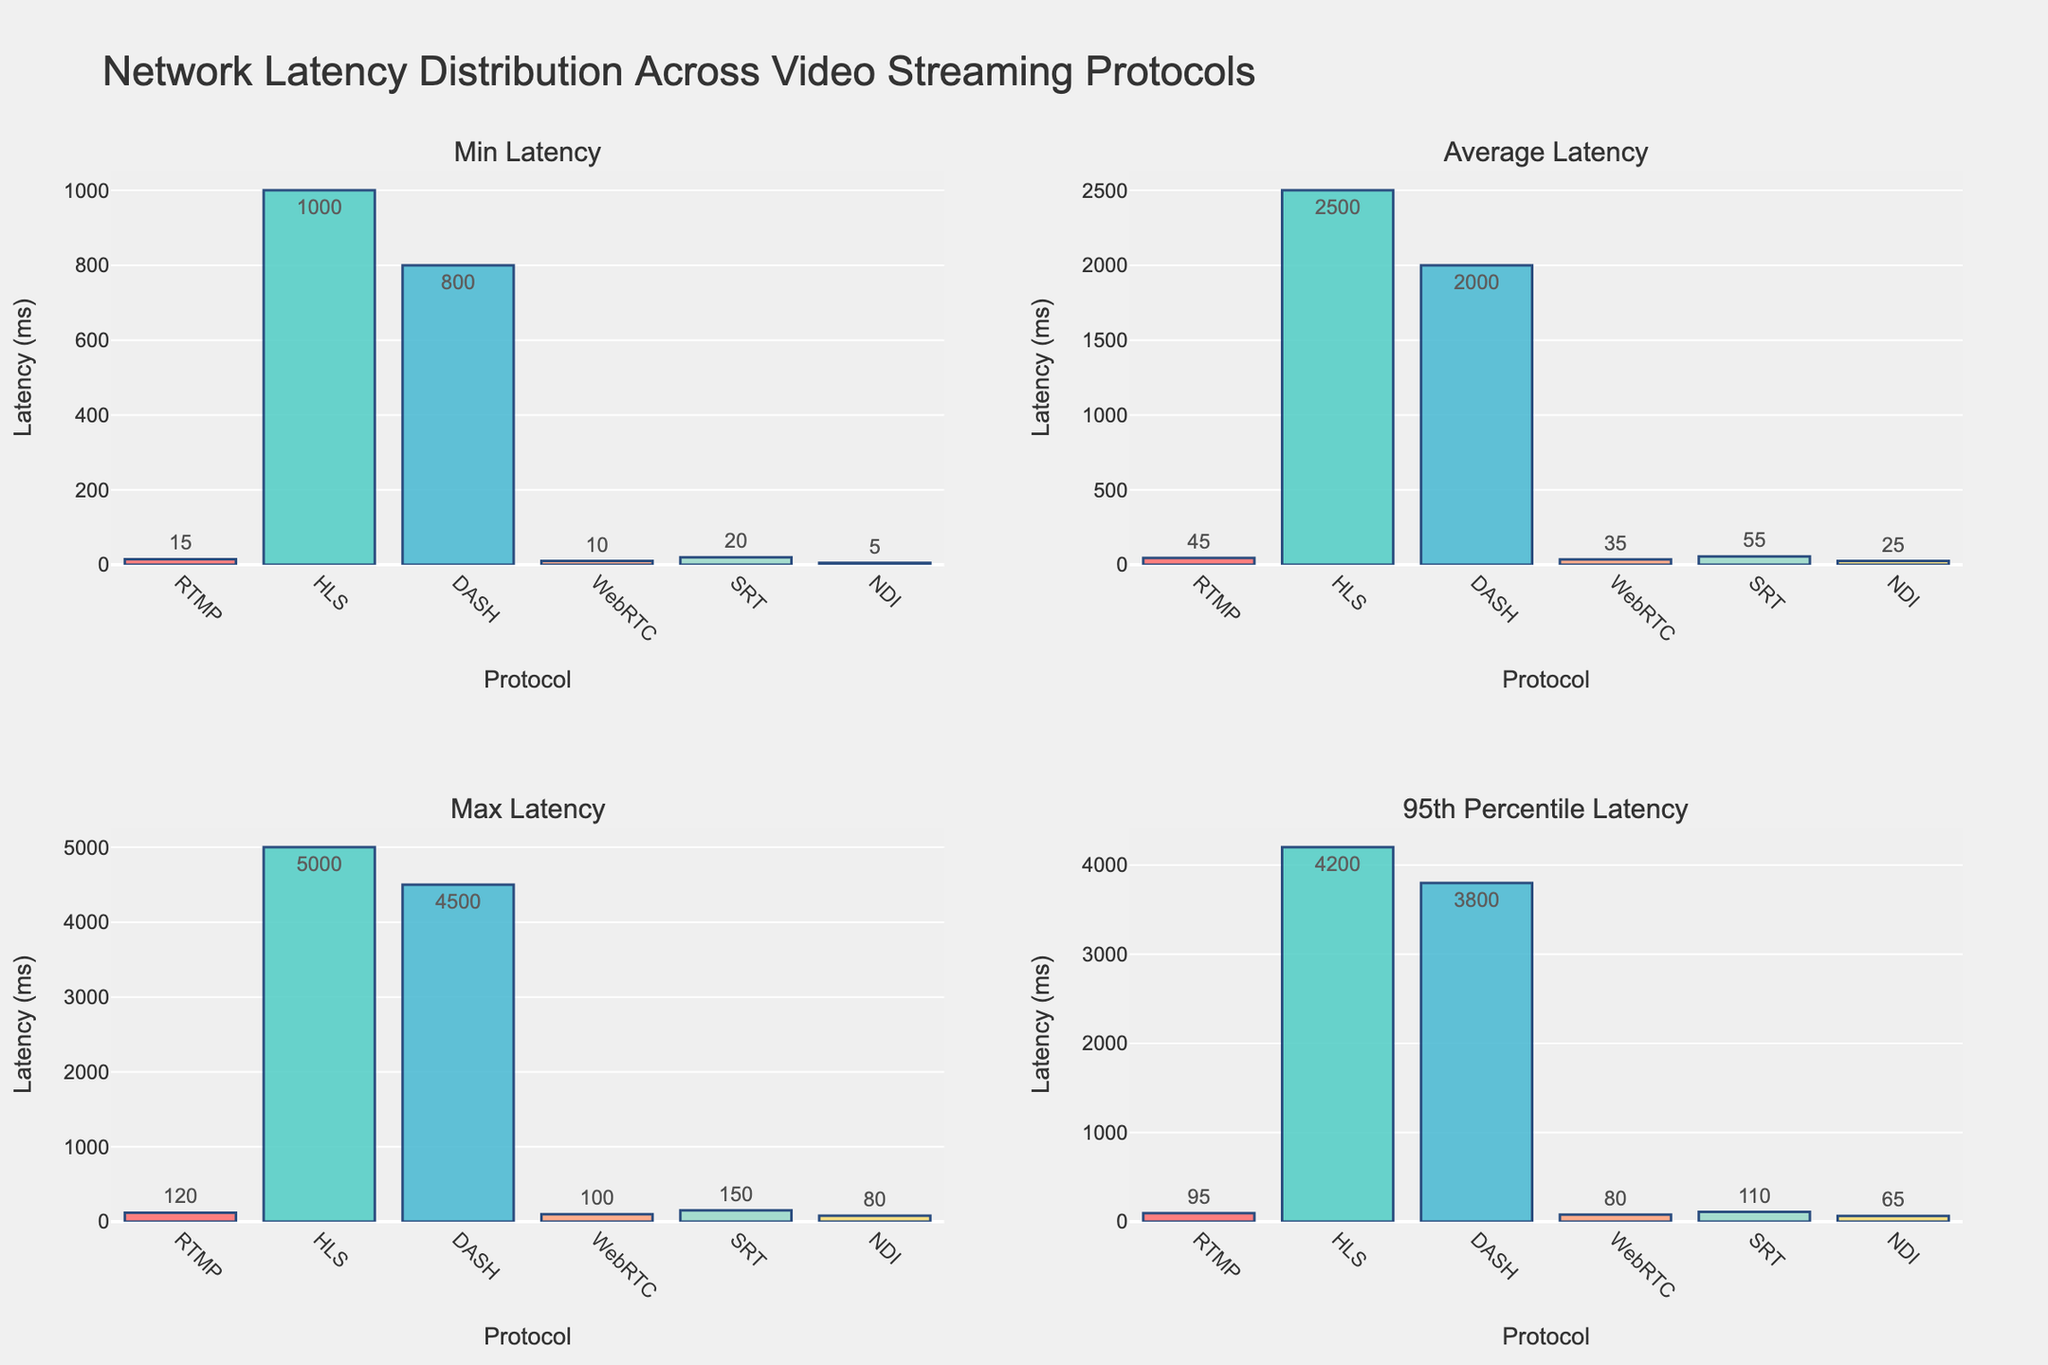What is the title of the figure? The title of the plot is generally located at the top of the figure, providing a summary of what the entire figure is about. In this case, the title reads, "Volunteer Hours Across Social Welfare Organizations in Korea," indicating the main topic being visualized.
Answer: Volunteer Hours Across Social Welfare Organizations in Korea Which organization had the highest volunteer hours in 2022 in the bar chart? By examining the bars representing the year 2022 on the bar chart in the top right subplot, we can observe the heights of the bars for different organizations. The bar representing the "Korean Red Cross" is the highest, indicating it had the most volunteer hours in 2022.
Answer: Korean Red Cross How did the volunteer hours for "Good Neighbors" change from 2018 to 2022 as shown in the line chart? In the line chart in the top left subplot, trace the line corresponding to "Good Neighbors" from 2018 to 2022. In 2018, the hours were 80,000, while in 2022, they remained the same at 80,000. There is a dip and subsequent rise within the intervening years.
Answer: No change (80,000 to 80,000) What is the total number of volunteer hours for "ChildFund Korea" between 2018 and 2022? Sum the volunteer hours for "ChildFund Korea" for each year from the data points in any subplot. The years and respective hours are: 2018 (70,000), 2019 (72,000), 2020 (55,000), 2021 (60,000), 2022 (68,000). Adding them gives 70,000 + 72,000 + 55,000 + 60,000 + 68,000 = 325,000.
Answer: 325,000 Which year had the lowest overall volunteer hours when considering all organizations combined, based on the area chart? The area chart in the bottom left subplot shows stacked areas representing the cumulative volunteer hours for all organizations per year. The year with the smallest cumulative area height represents the overall lowest volunteer hours. This is visually identifiable as 2020.
Answer: 2020 How do the trends of volunteer hours for "Korea National Council on Social Welfare" and "Community Chest of Korea" compare from 2018 to 2022 in the scatter plot? Examine the scatter plot in the bottom right subplot. Both organizations follow a declining trend from 2019 to 2020 and then exhibit a rising trend from 2020 to 2022. However, "Korea National Council on Social Welfare" generally has higher values throughout.
Answer: Both declined then rose; "Korea National Council on Social Welfare" has higher values In the bar chart, which two organizations had the closest number of volunteer hours in 2021? Observe the positions of the bars for 2021 within the bar chart. "Good Neighbors" (70,000 hours) and "Habitat for Humanity Korea" (45,000 hours) show considerable proximity, with the difference between them being the smallest compared to other organizations.
Answer: Habitat for Humanity Korea and Korea Food for the Hungry International What is the range of volunteer hours for the "Korean Red Cross" from 2018 to 2022 as seen in the area chart? The range is calculated by subtracting the smallest number of volunteer hours from the largest for the "Korean Red Cross". From the data, the hours go from a maximum of 155,000 in 2019 to a minimum of 110,000 in 2020. Thus, the range is 155,000 - 110,000 = 45,000.
Answer: 45,000 